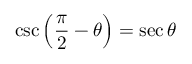Convert formula to latex. <formula><loc_0><loc_0><loc_500><loc_500>\csc \left ( { \frac { \pi } { 2 } } - \theta \right ) = \sec \theta</formula> 